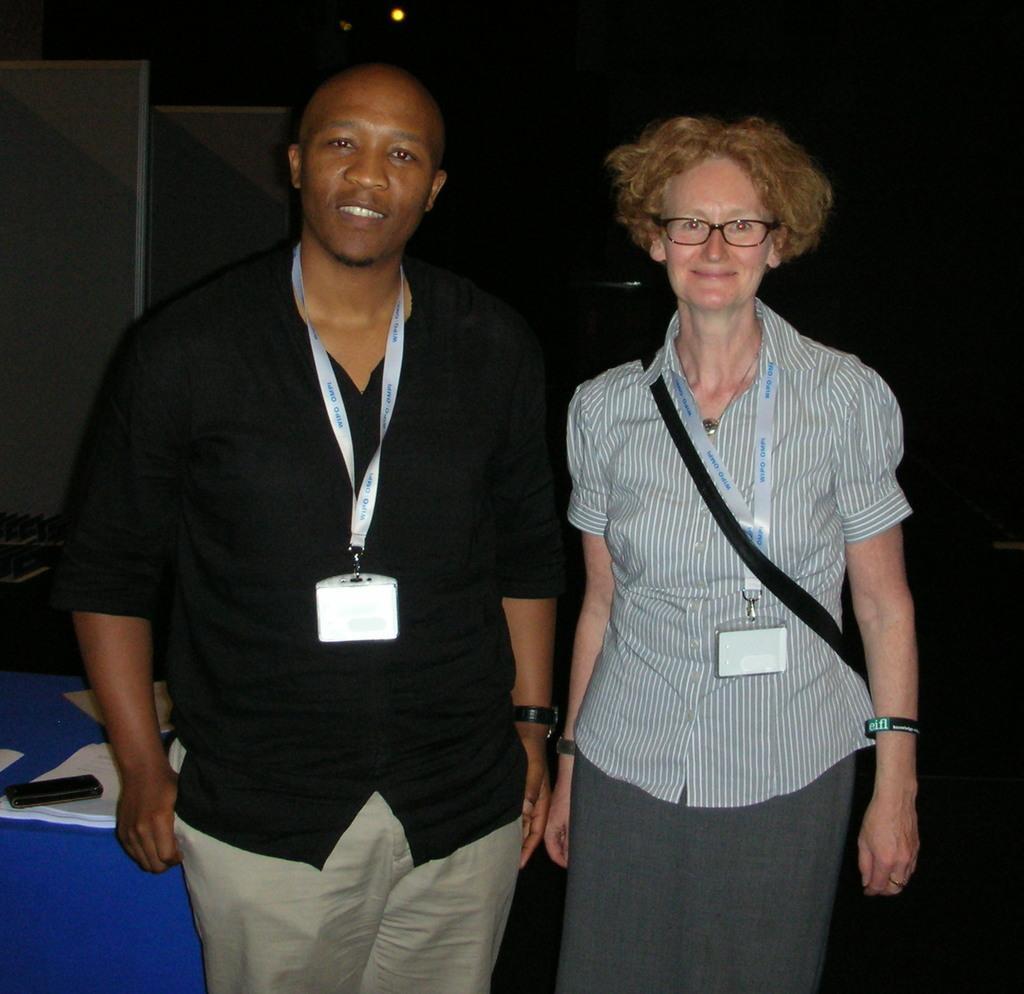Please provide a concise description of this image. In this image there is a man and a woman standing. They are wearing identity cards. They are smiling. Behind them there is a table. There are papers and an object on the table. The background is dark. 